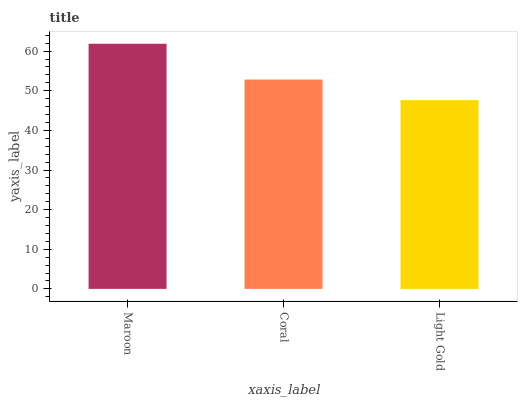Is Light Gold the minimum?
Answer yes or no. Yes. Is Maroon the maximum?
Answer yes or no. Yes. Is Coral the minimum?
Answer yes or no. No. Is Coral the maximum?
Answer yes or no. No. Is Maroon greater than Coral?
Answer yes or no. Yes. Is Coral less than Maroon?
Answer yes or no. Yes. Is Coral greater than Maroon?
Answer yes or no. No. Is Maroon less than Coral?
Answer yes or no. No. Is Coral the high median?
Answer yes or no. Yes. Is Coral the low median?
Answer yes or no. Yes. Is Maroon the high median?
Answer yes or no. No. Is Light Gold the low median?
Answer yes or no. No. 